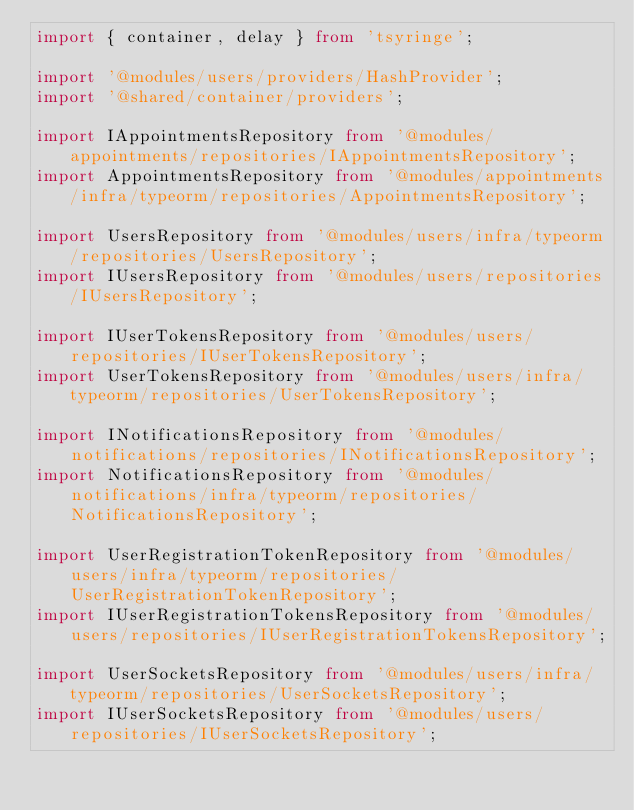Convert code to text. <code><loc_0><loc_0><loc_500><loc_500><_TypeScript_>import { container, delay } from 'tsyringe';

import '@modules/users/providers/HashProvider';
import '@shared/container/providers';

import IAppointmentsRepository from '@modules/appointments/repositories/IAppointmentsRepository';
import AppointmentsRepository from '@modules/appointments/infra/typeorm/repositories/AppointmentsRepository';

import UsersRepository from '@modules/users/infra/typeorm/repositories/UsersRepository';
import IUsersRepository from '@modules/users/repositories/IUsersRepository';

import IUserTokensRepository from '@modules/users/repositories/IUserTokensRepository';
import UserTokensRepository from '@modules/users/infra/typeorm/repositories/UserTokensRepository';

import INotificationsRepository from '@modules/notifications/repositories/INotificationsRepository';
import NotificationsRepository from '@modules/notifications/infra/typeorm/repositories/NotificationsRepository';

import UserRegistrationTokenRepository from '@modules/users/infra/typeorm/repositories/UserRegistrationTokenRepository';
import IUserRegistrationTokensRepository from '@modules/users/repositories/IUserRegistrationTokensRepository';

import UserSocketsRepository from '@modules/users/infra/typeorm/repositories/UserSocketsRepository';
import IUserSocketsRepository from '@modules/users/repositories/IUserSocketsRepository';
</code> 